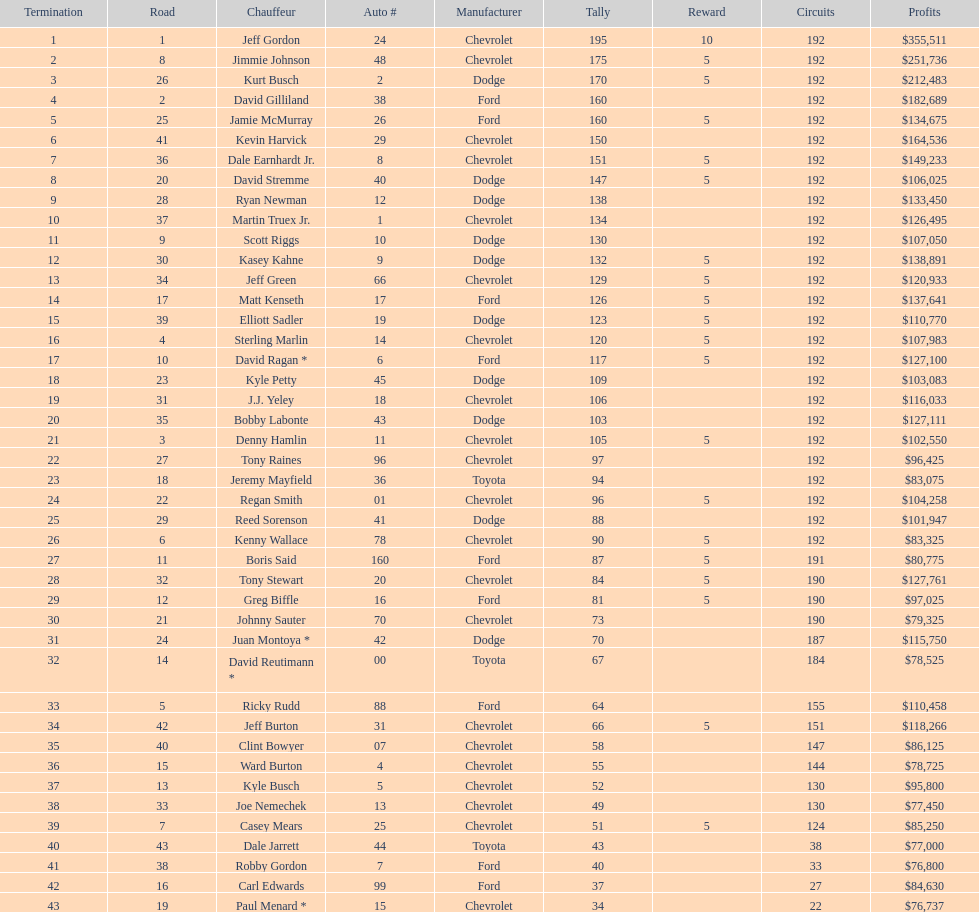Would you be able to parse every entry in this table? {'header': ['Termination', 'Road', 'Chauffeur', 'Auto #', 'Manufacturer', 'Tally', 'Reward', 'Circuits', 'Profits'], 'rows': [['1', '1', 'Jeff Gordon', '24', 'Chevrolet', '195', '10', '192', '$355,511'], ['2', '8', 'Jimmie Johnson', '48', 'Chevrolet', '175', '5', '192', '$251,736'], ['3', '26', 'Kurt Busch', '2', 'Dodge', '170', '5', '192', '$212,483'], ['4', '2', 'David Gilliland', '38', 'Ford', '160', '', '192', '$182,689'], ['5', '25', 'Jamie McMurray', '26', 'Ford', '160', '5', '192', '$134,675'], ['6', '41', 'Kevin Harvick', '29', 'Chevrolet', '150', '', '192', '$164,536'], ['7', '36', 'Dale Earnhardt Jr.', '8', 'Chevrolet', '151', '5', '192', '$149,233'], ['8', '20', 'David Stremme', '40', 'Dodge', '147', '5', '192', '$106,025'], ['9', '28', 'Ryan Newman', '12', 'Dodge', '138', '', '192', '$133,450'], ['10', '37', 'Martin Truex Jr.', '1', 'Chevrolet', '134', '', '192', '$126,495'], ['11', '9', 'Scott Riggs', '10', 'Dodge', '130', '', '192', '$107,050'], ['12', '30', 'Kasey Kahne', '9', 'Dodge', '132', '5', '192', '$138,891'], ['13', '34', 'Jeff Green', '66', 'Chevrolet', '129', '5', '192', '$120,933'], ['14', '17', 'Matt Kenseth', '17', 'Ford', '126', '5', '192', '$137,641'], ['15', '39', 'Elliott Sadler', '19', 'Dodge', '123', '5', '192', '$110,770'], ['16', '4', 'Sterling Marlin', '14', 'Chevrolet', '120', '5', '192', '$107,983'], ['17', '10', 'David Ragan *', '6', 'Ford', '117', '5', '192', '$127,100'], ['18', '23', 'Kyle Petty', '45', 'Dodge', '109', '', '192', '$103,083'], ['19', '31', 'J.J. Yeley', '18', 'Chevrolet', '106', '', '192', '$116,033'], ['20', '35', 'Bobby Labonte', '43', 'Dodge', '103', '', '192', '$127,111'], ['21', '3', 'Denny Hamlin', '11', 'Chevrolet', '105', '5', '192', '$102,550'], ['22', '27', 'Tony Raines', '96', 'Chevrolet', '97', '', '192', '$96,425'], ['23', '18', 'Jeremy Mayfield', '36', 'Toyota', '94', '', '192', '$83,075'], ['24', '22', 'Regan Smith', '01', 'Chevrolet', '96', '5', '192', '$104,258'], ['25', '29', 'Reed Sorenson', '41', 'Dodge', '88', '', '192', '$101,947'], ['26', '6', 'Kenny Wallace', '78', 'Chevrolet', '90', '5', '192', '$83,325'], ['27', '11', 'Boris Said', '160', 'Ford', '87', '5', '191', '$80,775'], ['28', '32', 'Tony Stewart', '20', 'Chevrolet', '84', '5', '190', '$127,761'], ['29', '12', 'Greg Biffle', '16', 'Ford', '81', '5', '190', '$97,025'], ['30', '21', 'Johnny Sauter', '70', 'Chevrolet', '73', '', '190', '$79,325'], ['31', '24', 'Juan Montoya *', '42', 'Dodge', '70', '', '187', '$115,750'], ['32', '14', 'David Reutimann *', '00', 'Toyota', '67', '', '184', '$78,525'], ['33', '5', 'Ricky Rudd', '88', 'Ford', '64', '', '155', '$110,458'], ['34', '42', 'Jeff Burton', '31', 'Chevrolet', '66', '5', '151', '$118,266'], ['35', '40', 'Clint Bowyer', '07', 'Chevrolet', '58', '', '147', '$86,125'], ['36', '15', 'Ward Burton', '4', 'Chevrolet', '55', '', '144', '$78,725'], ['37', '13', 'Kyle Busch', '5', 'Chevrolet', '52', '', '130', '$95,800'], ['38', '33', 'Joe Nemechek', '13', 'Chevrolet', '49', '', '130', '$77,450'], ['39', '7', 'Casey Mears', '25', 'Chevrolet', '51', '5', '124', '$85,250'], ['40', '43', 'Dale Jarrett', '44', 'Toyota', '43', '', '38', '$77,000'], ['41', '38', 'Robby Gordon', '7', 'Ford', '40', '', '33', '$76,800'], ['42', '16', 'Carl Edwards', '99', 'Ford', '37', '', '27', '$84,630'], ['43', '19', 'Paul Menard *', '15', 'Chevrolet', '34', '', '22', '$76,737']]} How many drivers earned no bonus for this race? 23. 